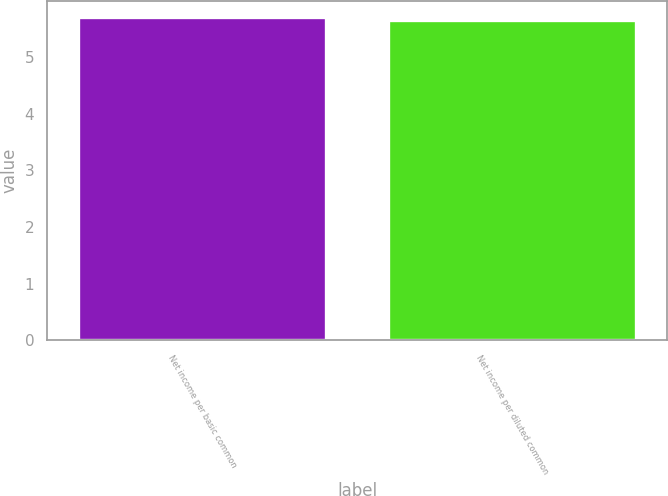Convert chart. <chart><loc_0><loc_0><loc_500><loc_500><bar_chart><fcel>Net income per basic common<fcel>Net income per diluted common<nl><fcel>5.7<fcel>5.65<nl></chart> 